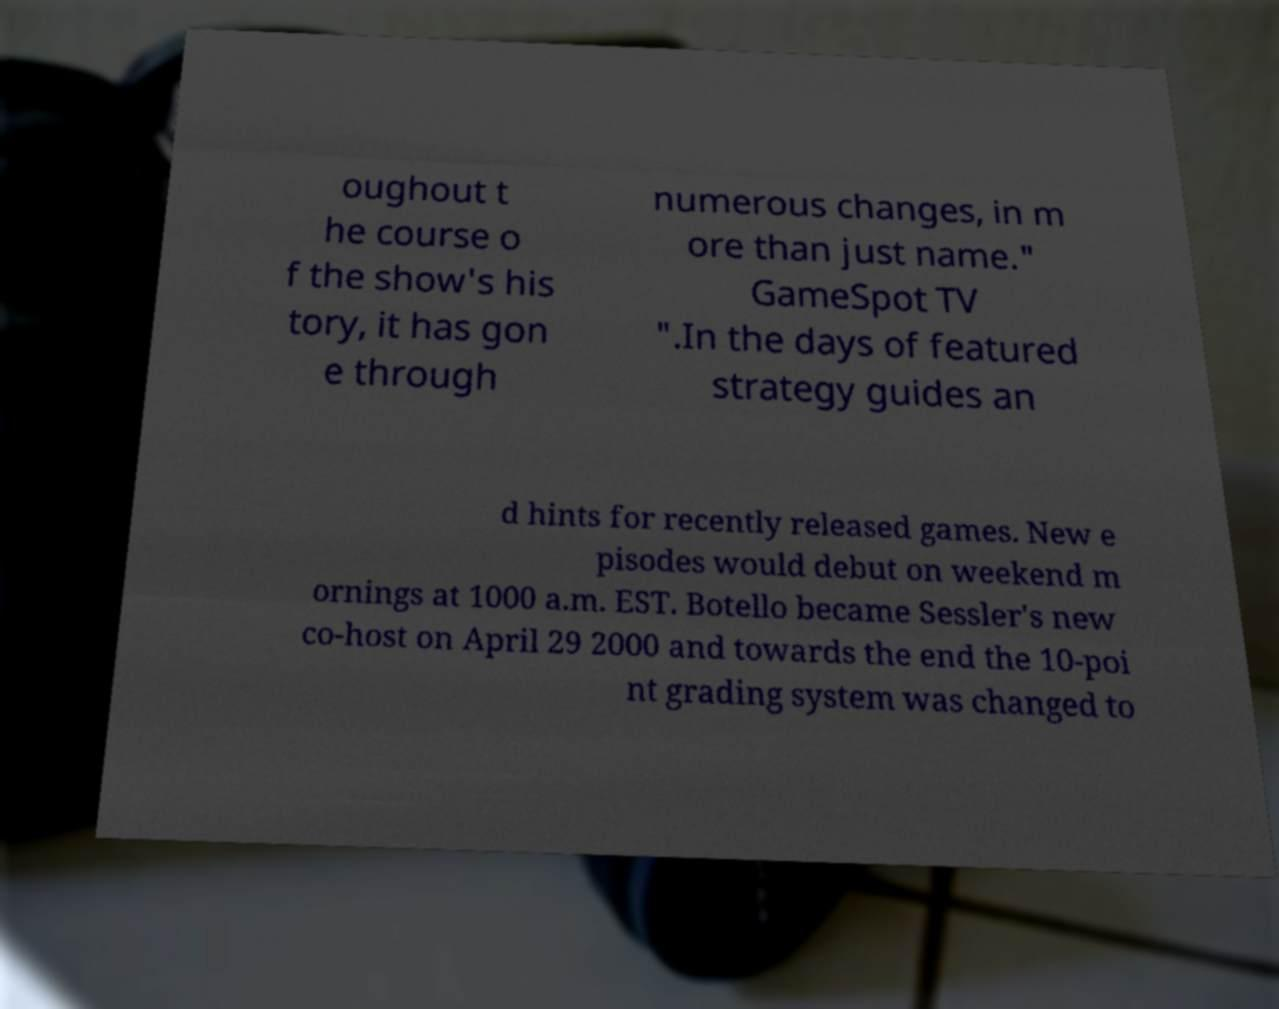Could you extract and type out the text from this image? oughout t he course o f the show's his tory, it has gon e through numerous changes, in m ore than just name." GameSpot TV ".In the days of featured strategy guides an d hints for recently released games. New e pisodes would debut on weekend m ornings at 1000 a.m. EST. Botello became Sessler's new co-host on April 29 2000 and towards the end the 10-poi nt grading system was changed to 